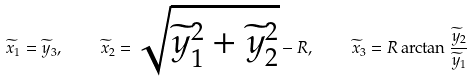Convert formula to latex. <formula><loc_0><loc_0><loc_500><loc_500>\widetilde { x } _ { 1 } = \widetilde { y } _ { 3 } , \quad \widetilde { x } _ { 2 } = \sqrt { \widetilde { y } _ { 1 } ^ { 2 } + \widetilde { y } _ { 2 } ^ { 2 } } - R , \quad \widetilde { x } _ { 3 } = R \arctan \frac { \widetilde { y } _ { 2 } } { \widetilde { y } _ { 1 } }</formula> 